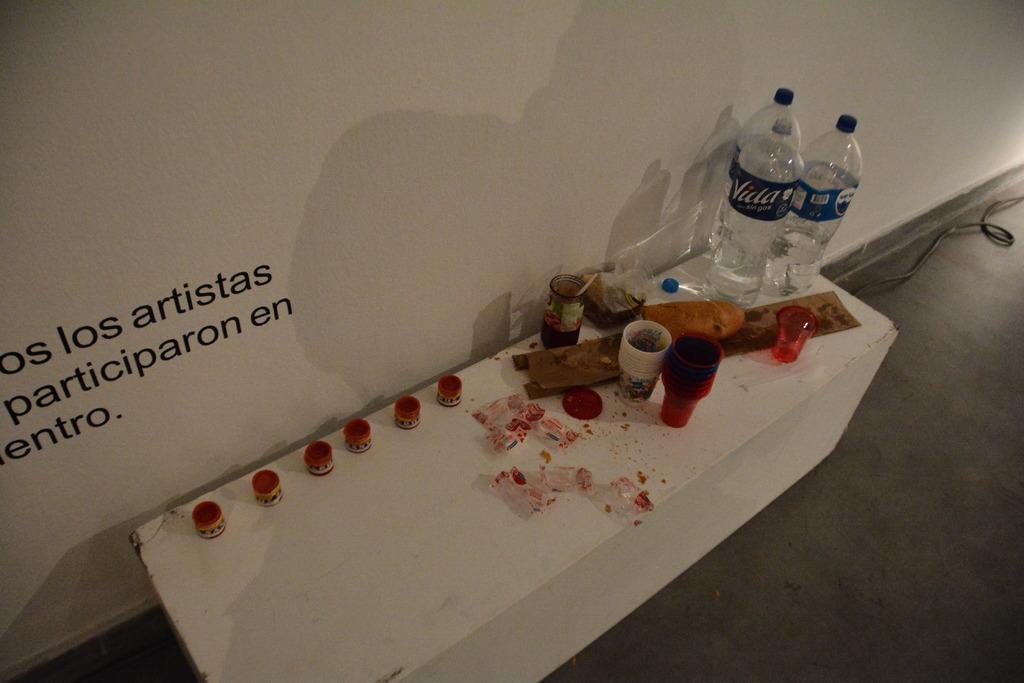How would you summarize this image in a sentence or two? Here we can see that a table on the floor and some glasses on it, and water bottles ,and some other objects ,and here is the wall, and something written on it. 